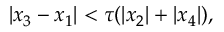Convert formula to latex. <formula><loc_0><loc_0><loc_500><loc_500>| x _ { 3 } - x _ { 1 } | < \tau ( | x _ { 2 } | + | x _ { 4 } | ) ,</formula> 